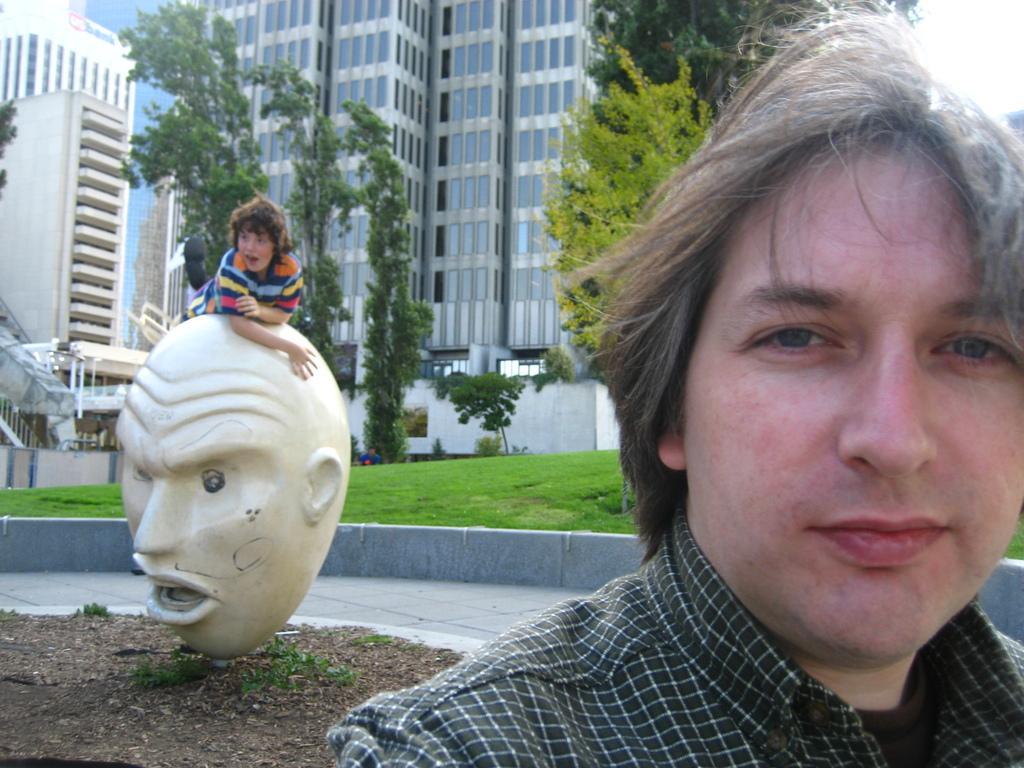How would you summarize this image in a sentence or two? In this image in the foreground there is one person, and in the background there is a statue and one boy, sand, grass, trees, plants, buildings and some other objects. 